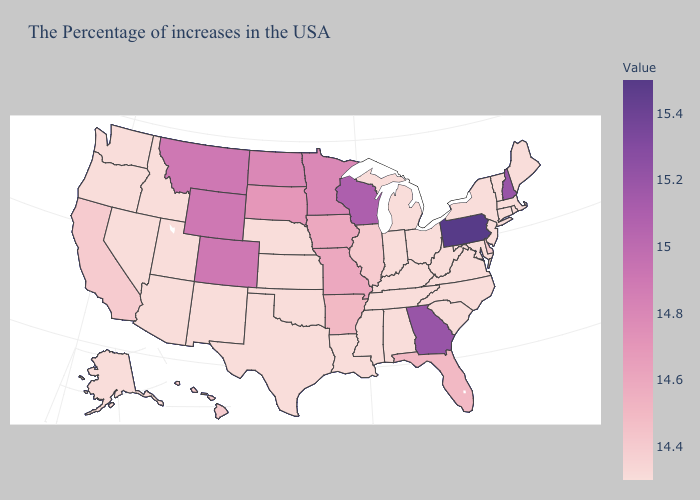Does Louisiana have a higher value than Pennsylvania?
Write a very short answer. No. Among the states that border Wisconsin , which have the lowest value?
Be succinct. Michigan. Which states have the highest value in the USA?
Write a very short answer. Pennsylvania. Does Delaware have the lowest value in the USA?
Write a very short answer. No. 